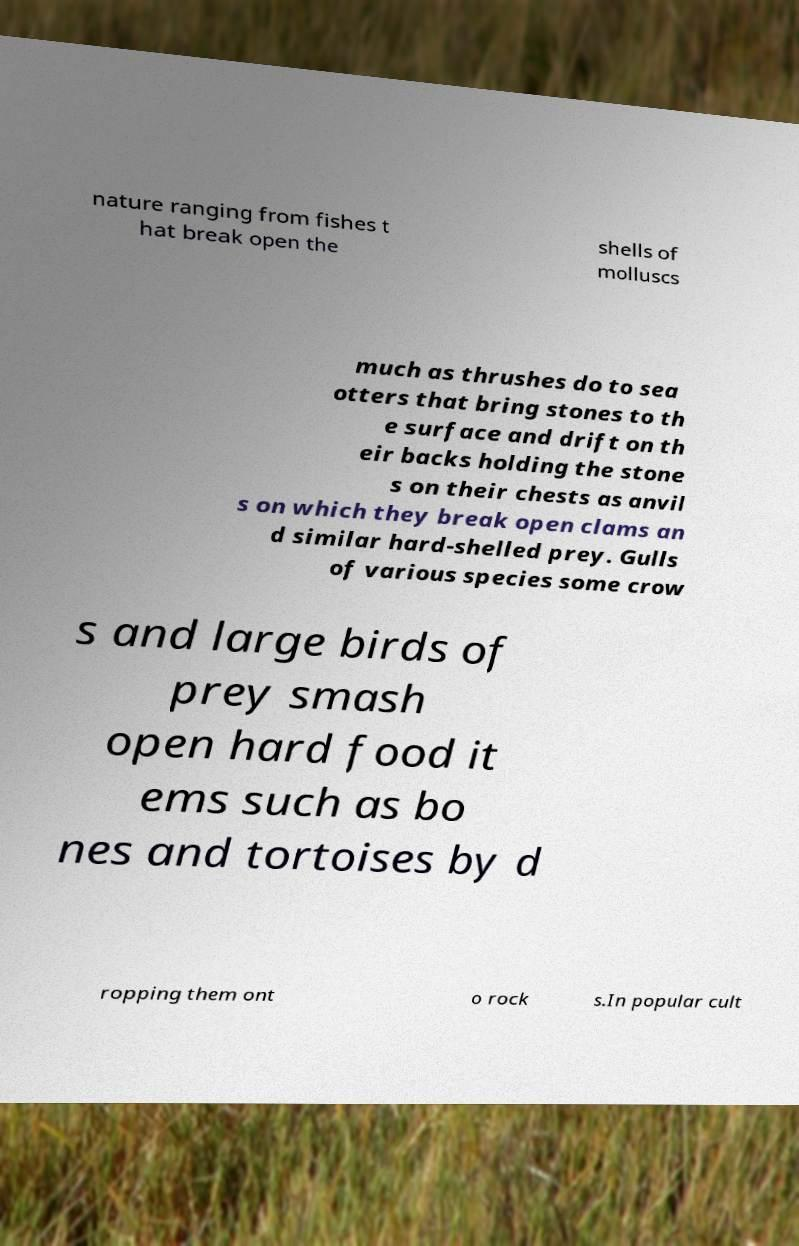What messages or text are displayed in this image? I need them in a readable, typed format. nature ranging from fishes t hat break open the shells of molluscs much as thrushes do to sea otters that bring stones to th e surface and drift on th eir backs holding the stone s on their chests as anvil s on which they break open clams an d similar hard-shelled prey. Gulls of various species some crow s and large birds of prey smash open hard food it ems such as bo nes and tortoises by d ropping them ont o rock s.In popular cult 